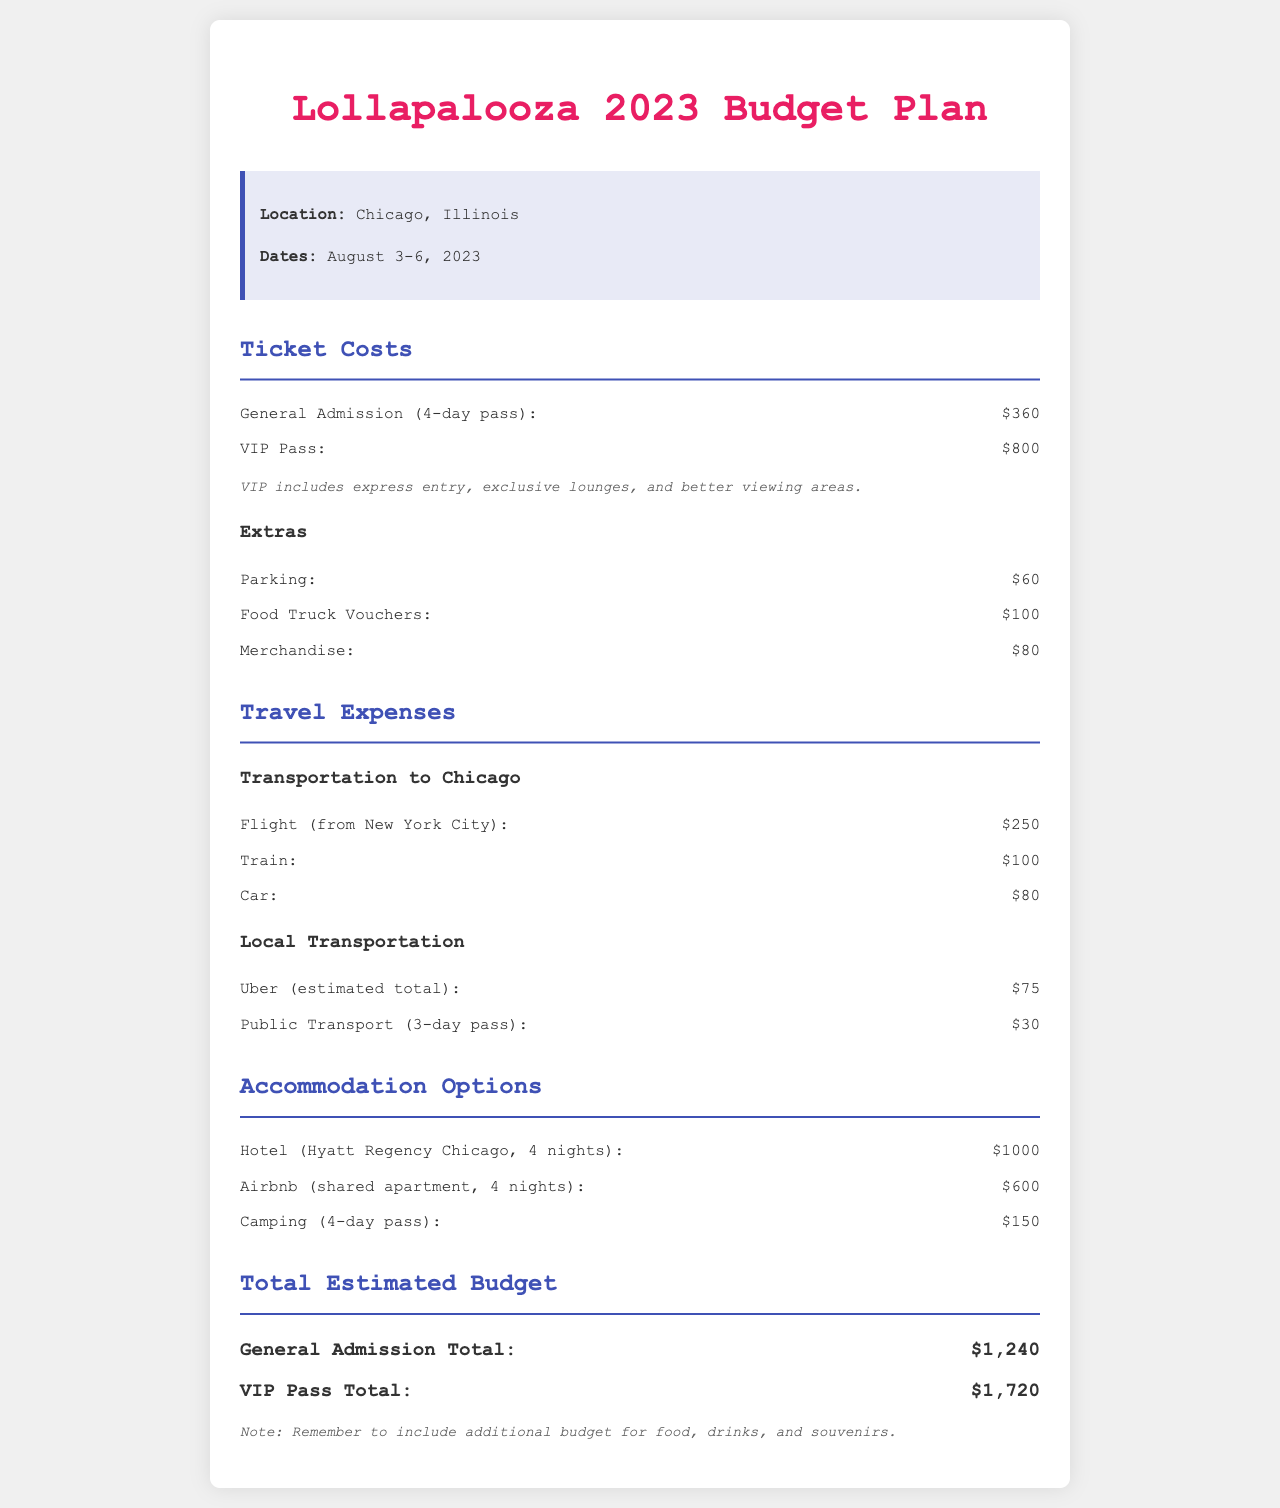What are the dates of the festival? The dates of the festival are clearly stated in the document, noting it runs from August 3-6, 2023.
Answer: August 3-6, 2023 What is the cost of a VIP pass? The document specifies the cost of a VIP pass as $800, which is outlined under Ticket Costs.
Answer: $800 How much does parking cost? The cost of parking is listed in the Extras section, where it is specifically noted as $60.
Answer: $60 What is the total cost for General Admission? The total cost for General Admission is mentioned at the end of the budget as $1,240.
Answer: $1,240 What is the cheapest accommodation option? The document lists camping as the cheapest accommodation option, costing $150 for 4 days.
Answer: $150 How much would it cost to fly from New York City? The flight cost from New York City is specifically mentioned as $250 in the Travel Expenses section.
Answer: $250 What is the total estimated budget for a VIP Pass? The total estimated budget for a VIP Pass, including all associated costs, is stated as $1,720.
Answer: $1,720 Which local transportation option costs $30? The document indicates that a Public Transport 3-day pass costs $30, found under Local Transportation.
Answer: $30 What type of accommodation is listed at $1,000? The document specifies that a hotel at Hyatt Regency Chicago for 4 nights is the accommodation option listed at $1,000.
Answer: Hotel (Hyatt Regency Chicago, 4 nights) 